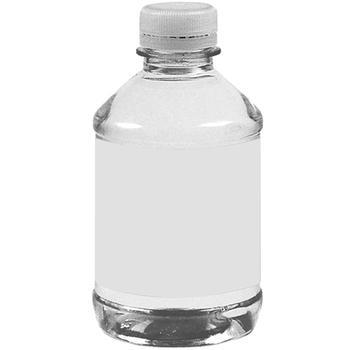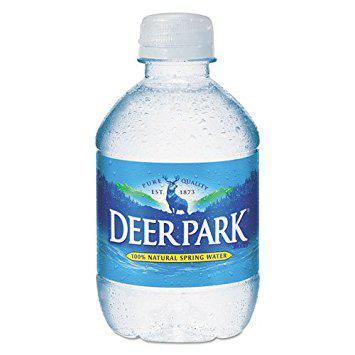The first image is the image on the left, the second image is the image on the right. For the images displayed, is the sentence "One of the bottles has a Kirkland label." factually correct? Answer yes or no. No. 